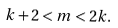Convert formula to latex. <formula><loc_0><loc_0><loc_500><loc_500>k + 2 < m < 2 k .</formula> 